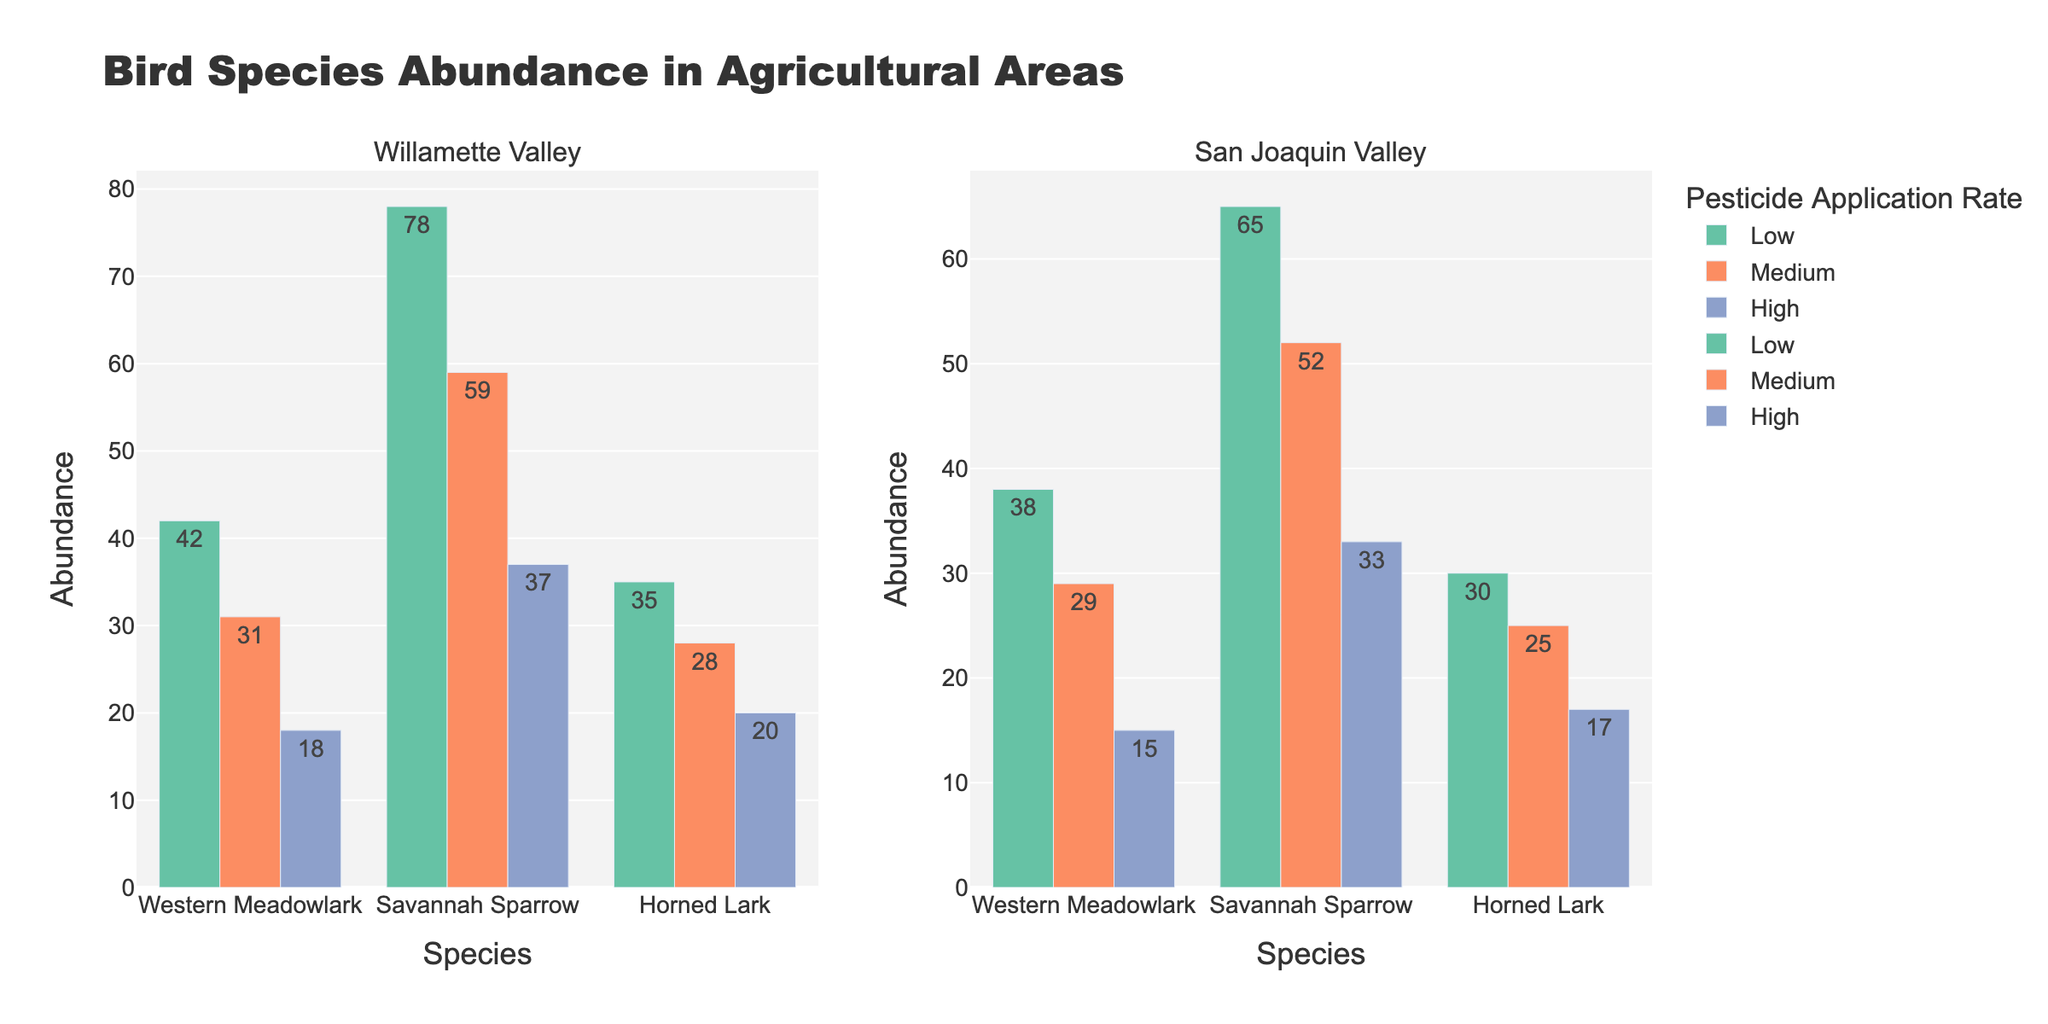What is the title of the figure? The title should be at the top of the figure, often centered for increased visibility.
Answer: Bird Species Abundance in Agricultural Areas What are the three pesticide application rates shown in the figure? The figure uses color-coded bars to represent different pesticide application rates which are usually indicated in the legend.
Answer: Low, Medium, High Which bird species has the highest abundance in the Willamette Valley with low pesticide application? Look at the bars in the "Willamette Valley" subplot with the color representing "Low" pesticide application and identify the tallest bar for species.
Answer: Savannah Sparrow What is the total abundance of Western Meadowlark in both locations with medium pesticide application? Find the bar representing Western Meadowlark in both subplots with the color for "Medium". Sum their heights. 31 (Willamette Valley) + 29 (San Joaquin Valley).
Answer: 60 How does the abundance of Horned Larks in the San Joaquin Valley change from low to high pesticide application? Compare the heights of the bars representing Horned Lark in San Joaquin Valley for low, medium, and high pesticide rates to understand the change. Low: 30, Medium: 25, High: 17.
Answer: Decreases Is the abundance of Savannah Sparrows generally higher in the Willamette Valley or the San Joaquin Valley for all pesticide application rates? Compare the corresponding bars for Savannah Sparrows across all pesticide rates between the two subplots, then summarize the general trend.
Answer: Willamette Valley Which location shows a greater decline in Western Meadowlark abundance as pesticide rate increases from low to high? Compare the decline in bar height for Western Meadowlark from low to high pesticide rates for both locations. Willamette Valley: 42-18=24, San Joaquin Valley: 38-15=23.
Answer: Willamette Valley For low pesticide rates, how does the total abundance of species in the Willamette Valley compare to the San Joaquin Valley? Sum all species abundances for low pesticide rates in both locations and compare. Willamette Valley: 42+78+35=155, San Joaquin Valley: 38+65+30=133.
Answer: Higher in Willamette Valley What is the difference in abundance of Savannah Sparrows and Horned Larks in the Willamette Valley with high pesticide application? Subtract the abundance of Horned Larks from Savannah Sparrows in the Willamette Valley with high pesticide application (37-20).
Answer: 17 Which species shows the least change in abundance across different pesticide application rates in the San Joaquin Valley? Compare the bar heights for each species in the San Joaquin Valley and determine which one has the smallest overall change between the highest and lowest values. Western Meadowlark changes from 38 to 15, Savannah Sparrow from 65 to 33, and Horned Lark from 30 to 17.
Answer: Horned Lark 